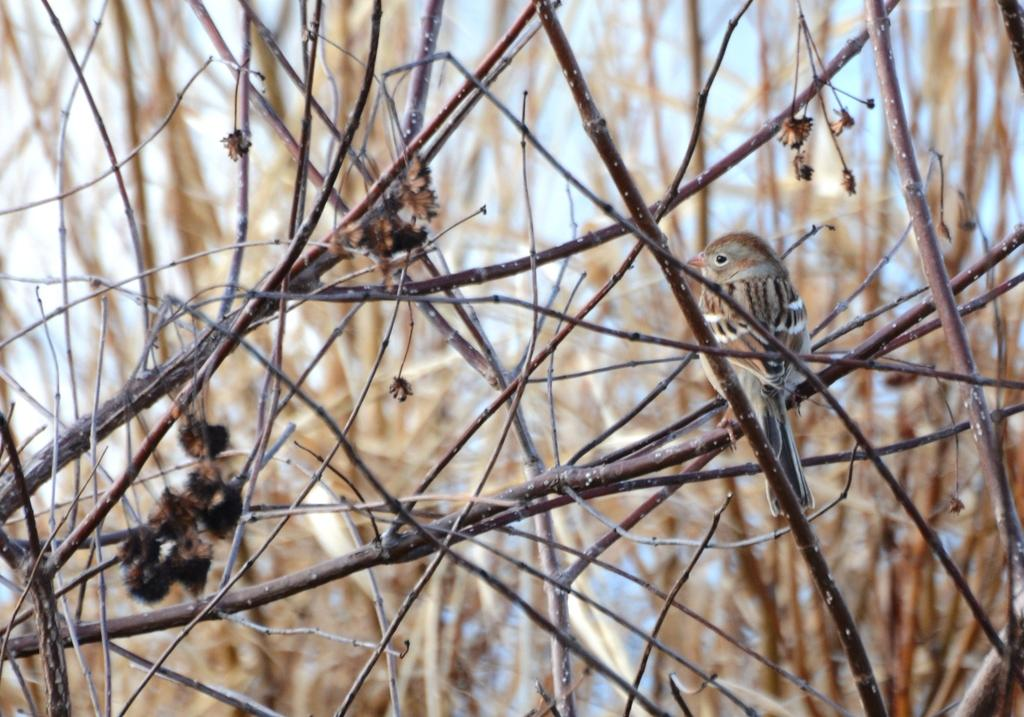What type of bird is in the image? There is a sparrow in the image. Where is the sparrow located in the image? The sparrow is sitting on a stem. What is the condition of the stems in the image? The stems are dried. What type of environment is depicted in the image? The image appears to be taken in a forest setting. How many companies are visible in the image? There are no companies present in the image; it features a sparrow sitting on a stem in a forest setting. 